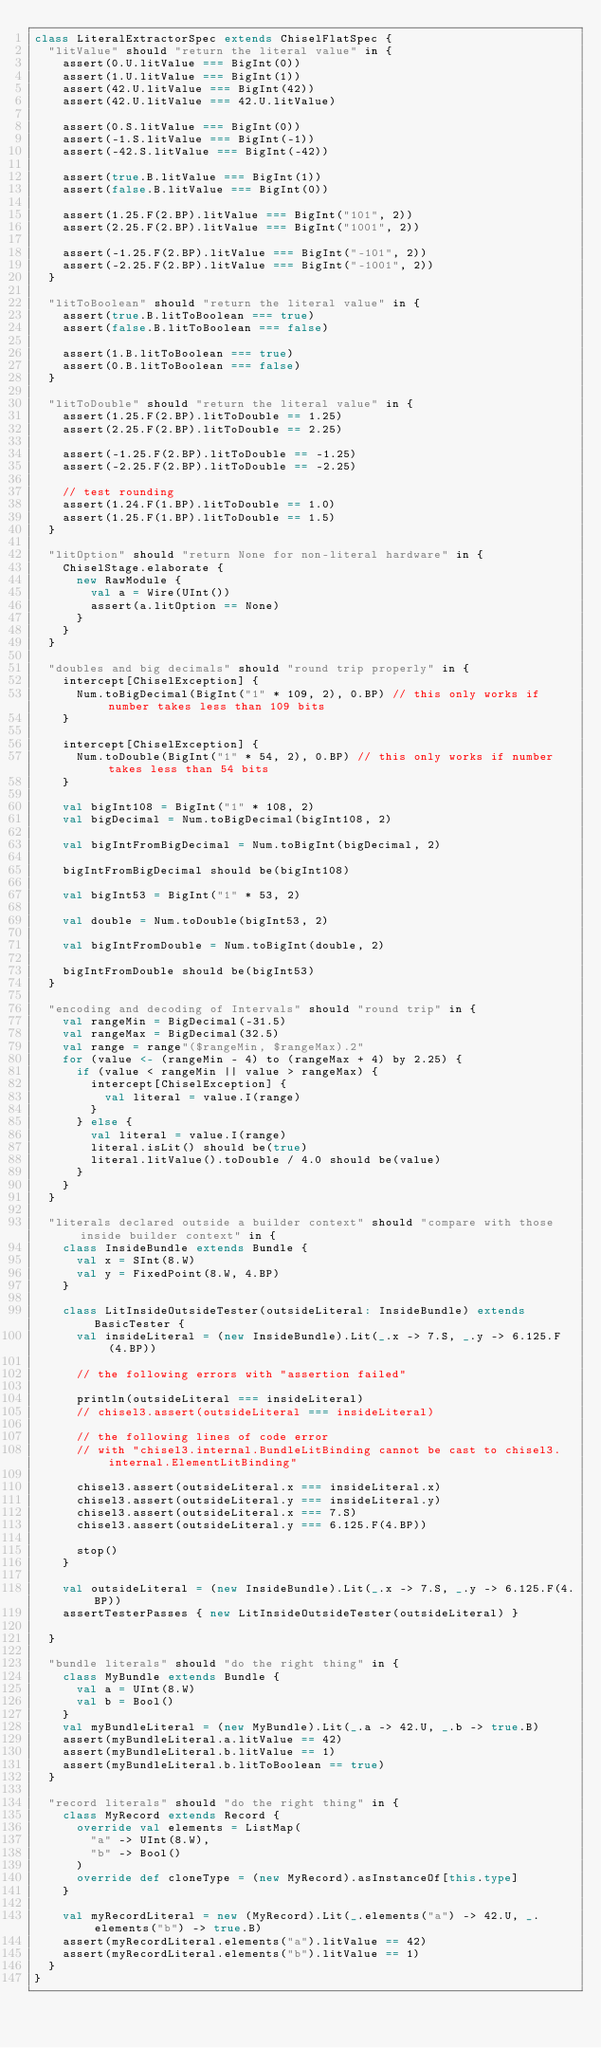Convert code to text. <code><loc_0><loc_0><loc_500><loc_500><_Scala_>class LiteralExtractorSpec extends ChiselFlatSpec {
  "litValue" should "return the literal value" in {
    assert(0.U.litValue === BigInt(0))
    assert(1.U.litValue === BigInt(1))
    assert(42.U.litValue === BigInt(42))
    assert(42.U.litValue === 42.U.litValue)

    assert(0.S.litValue === BigInt(0))
    assert(-1.S.litValue === BigInt(-1))
    assert(-42.S.litValue === BigInt(-42))

    assert(true.B.litValue === BigInt(1))
    assert(false.B.litValue === BigInt(0))

    assert(1.25.F(2.BP).litValue === BigInt("101", 2))
    assert(2.25.F(2.BP).litValue === BigInt("1001", 2))

    assert(-1.25.F(2.BP).litValue === BigInt("-101", 2))
    assert(-2.25.F(2.BP).litValue === BigInt("-1001", 2))
  }

  "litToBoolean" should "return the literal value" in {
    assert(true.B.litToBoolean === true)
    assert(false.B.litToBoolean === false)

    assert(1.B.litToBoolean === true)
    assert(0.B.litToBoolean === false)
  }

  "litToDouble" should "return the literal value" in {
    assert(1.25.F(2.BP).litToDouble == 1.25)
    assert(2.25.F(2.BP).litToDouble == 2.25)

    assert(-1.25.F(2.BP).litToDouble == -1.25)
    assert(-2.25.F(2.BP).litToDouble == -2.25)

    // test rounding
    assert(1.24.F(1.BP).litToDouble == 1.0)
    assert(1.25.F(1.BP).litToDouble == 1.5)
  }

  "litOption" should "return None for non-literal hardware" in {
    ChiselStage.elaborate {
      new RawModule {
        val a = Wire(UInt())
        assert(a.litOption == None)
      }
    }
  }

  "doubles and big decimals" should "round trip properly" in {
    intercept[ChiselException] {
      Num.toBigDecimal(BigInt("1" * 109, 2), 0.BP) // this only works if number takes less than 109 bits
    }

    intercept[ChiselException] {
      Num.toDouble(BigInt("1" * 54, 2), 0.BP) // this only works if number takes less than 54 bits
    }

    val bigInt108 = BigInt("1" * 108, 2)
    val bigDecimal = Num.toBigDecimal(bigInt108, 2)

    val bigIntFromBigDecimal = Num.toBigInt(bigDecimal, 2)

    bigIntFromBigDecimal should be(bigInt108)

    val bigInt53 = BigInt("1" * 53, 2)

    val double = Num.toDouble(bigInt53, 2)

    val bigIntFromDouble = Num.toBigInt(double, 2)

    bigIntFromDouble should be(bigInt53)
  }

  "encoding and decoding of Intervals" should "round trip" in {
    val rangeMin = BigDecimal(-31.5)
    val rangeMax = BigDecimal(32.5)
    val range = range"($rangeMin, $rangeMax).2"
    for (value <- (rangeMin - 4) to (rangeMax + 4) by 2.25) {
      if (value < rangeMin || value > rangeMax) {
        intercept[ChiselException] {
          val literal = value.I(range)
        }
      } else {
        val literal = value.I(range)
        literal.isLit() should be(true)
        literal.litValue().toDouble / 4.0 should be(value)
      }
    }
  }

  "literals declared outside a builder context" should "compare with those inside builder context" in {
    class InsideBundle extends Bundle {
      val x = SInt(8.W)
      val y = FixedPoint(8.W, 4.BP)
    }

    class LitInsideOutsideTester(outsideLiteral: InsideBundle) extends BasicTester {
      val insideLiteral = (new InsideBundle).Lit(_.x -> 7.S, _.y -> 6.125.F(4.BP))

      // the following errors with "assertion failed"

      println(outsideLiteral === insideLiteral)
      // chisel3.assert(outsideLiteral === insideLiteral)

      // the following lines of code error
      // with "chisel3.internal.BundleLitBinding cannot be cast to chisel3.internal.ElementLitBinding"

      chisel3.assert(outsideLiteral.x === insideLiteral.x)
      chisel3.assert(outsideLiteral.y === insideLiteral.y)
      chisel3.assert(outsideLiteral.x === 7.S)
      chisel3.assert(outsideLiteral.y === 6.125.F(4.BP))

      stop()
    }

    val outsideLiteral = (new InsideBundle).Lit(_.x -> 7.S, _.y -> 6.125.F(4.BP))
    assertTesterPasses { new LitInsideOutsideTester(outsideLiteral) }

  }

  "bundle literals" should "do the right thing" in {
    class MyBundle extends Bundle {
      val a = UInt(8.W)
      val b = Bool()
    }
    val myBundleLiteral = (new MyBundle).Lit(_.a -> 42.U, _.b -> true.B)
    assert(myBundleLiteral.a.litValue == 42)
    assert(myBundleLiteral.b.litValue == 1)
    assert(myBundleLiteral.b.litToBoolean == true)
  }

  "record literals" should "do the right thing" in {
    class MyRecord extends Record {
      override val elements = ListMap(
        "a" -> UInt(8.W),
        "b" -> Bool()
      )
      override def cloneType = (new MyRecord).asInstanceOf[this.type]
    }

    val myRecordLiteral = new (MyRecord).Lit(_.elements("a") -> 42.U, _.elements("b") -> true.B)
    assert(myRecordLiteral.elements("a").litValue == 42)
    assert(myRecordLiteral.elements("b").litValue == 1)
  }
}
</code> 